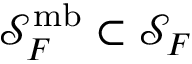Convert formula to latex. <formula><loc_0><loc_0><loc_500><loc_500>\mathcal { S } _ { F } ^ { m b } \subset \mathcal { S } _ { F }</formula> 